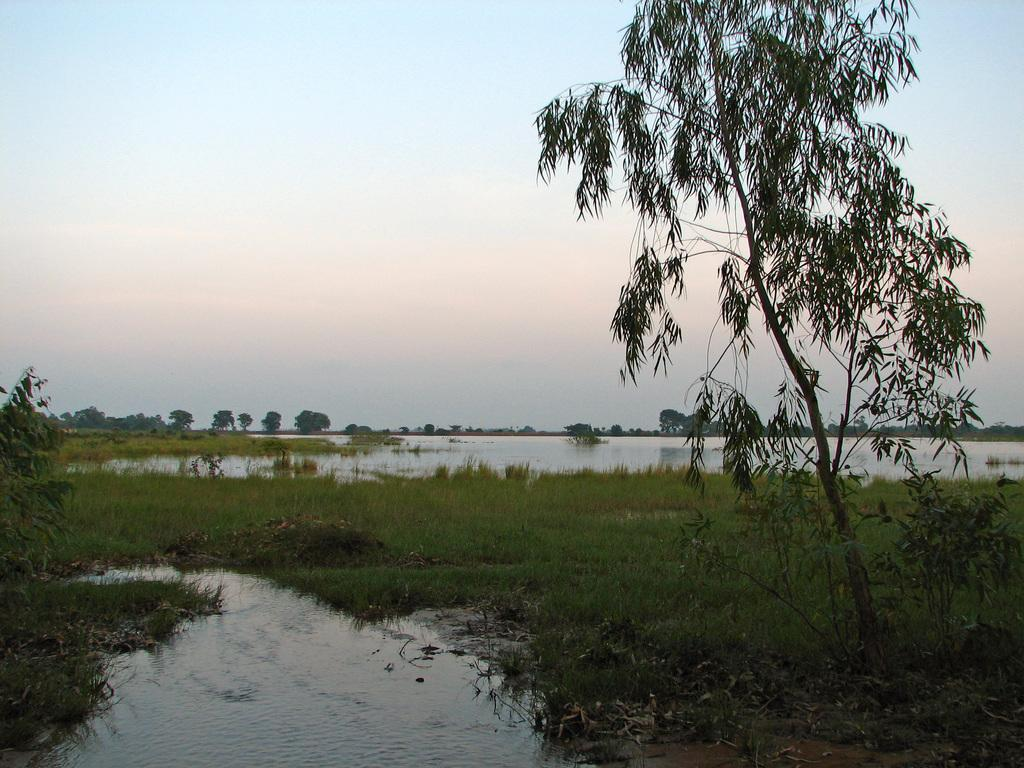What type of vegetation can be seen in the image? There are trees in the image. What natural element is visible besides the trees? There is water visible in the image. What is visible in the background of the image? The sky is visible in the image. What type of ground cover is present in the image? There is grass in the image. Can you see an arch in the image? There is no arch present in the image; it only features trees, water, sky, and grass. 